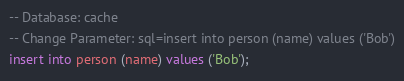Convert code to text. <code><loc_0><loc_0><loc_500><loc_500><_SQL_>-- Database: cache
-- Change Parameter: sql=insert into person (name) values ('Bob')
insert into person (name) values ('Bob');
</code> 